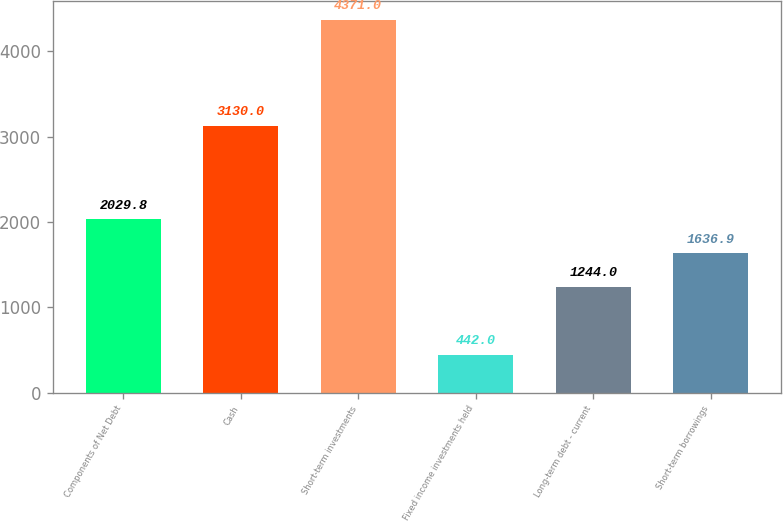Convert chart to OTSL. <chart><loc_0><loc_0><loc_500><loc_500><bar_chart><fcel>Components of Net Debt<fcel>Cash<fcel>Short-term investments<fcel>Fixed income investments held<fcel>Long-term debt - current<fcel>Short-term borrowings<nl><fcel>2029.8<fcel>3130<fcel>4371<fcel>442<fcel>1244<fcel>1636.9<nl></chart> 